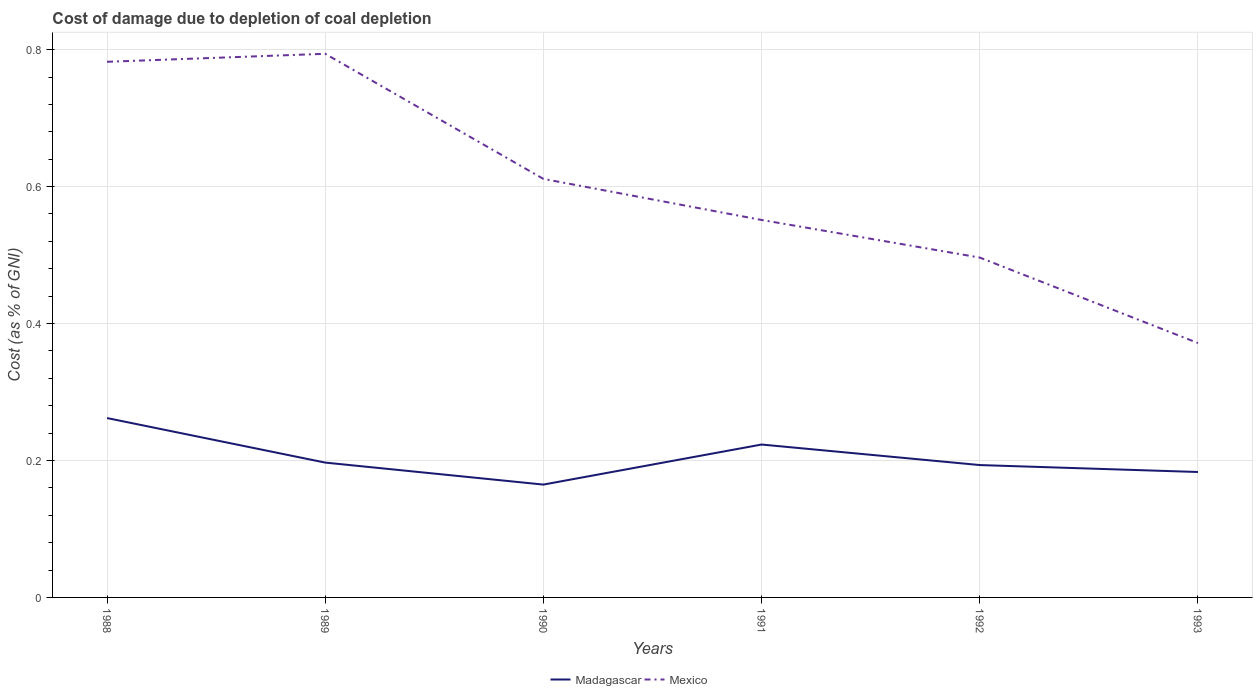How many different coloured lines are there?
Offer a terse response. 2. Does the line corresponding to Mexico intersect with the line corresponding to Madagascar?
Keep it short and to the point. No. Across all years, what is the maximum cost of damage caused due to coal depletion in Madagascar?
Provide a succinct answer. 0.16. What is the total cost of damage caused due to coal depletion in Madagascar in the graph?
Give a very brief answer. 0. What is the difference between the highest and the second highest cost of damage caused due to coal depletion in Mexico?
Your answer should be very brief. 0.42. What is the difference between two consecutive major ticks on the Y-axis?
Make the answer very short. 0.2. Are the values on the major ticks of Y-axis written in scientific E-notation?
Give a very brief answer. No. Does the graph contain any zero values?
Provide a succinct answer. No. Does the graph contain grids?
Your answer should be very brief. Yes. How many legend labels are there?
Your response must be concise. 2. What is the title of the graph?
Your answer should be very brief. Cost of damage due to depletion of coal depletion. Does "Brazil" appear as one of the legend labels in the graph?
Give a very brief answer. No. What is the label or title of the X-axis?
Keep it short and to the point. Years. What is the label or title of the Y-axis?
Your response must be concise. Cost (as % of GNI). What is the Cost (as % of GNI) in Madagascar in 1988?
Provide a short and direct response. 0.26. What is the Cost (as % of GNI) in Mexico in 1988?
Your answer should be compact. 0.78. What is the Cost (as % of GNI) in Madagascar in 1989?
Your answer should be very brief. 0.2. What is the Cost (as % of GNI) of Mexico in 1989?
Ensure brevity in your answer.  0.79. What is the Cost (as % of GNI) of Madagascar in 1990?
Give a very brief answer. 0.16. What is the Cost (as % of GNI) in Mexico in 1990?
Offer a very short reply. 0.61. What is the Cost (as % of GNI) of Madagascar in 1991?
Your response must be concise. 0.22. What is the Cost (as % of GNI) of Mexico in 1991?
Give a very brief answer. 0.55. What is the Cost (as % of GNI) in Madagascar in 1992?
Provide a succinct answer. 0.19. What is the Cost (as % of GNI) of Mexico in 1992?
Your answer should be compact. 0.5. What is the Cost (as % of GNI) in Madagascar in 1993?
Your answer should be compact. 0.18. What is the Cost (as % of GNI) in Mexico in 1993?
Your answer should be compact. 0.37. Across all years, what is the maximum Cost (as % of GNI) in Madagascar?
Make the answer very short. 0.26. Across all years, what is the maximum Cost (as % of GNI) of Mexico?
Ensure brevity in your answer.  0.79. Across all years, what is the minimum Cost (as % of GNI) in Madagascar?
Your answer should be very brief. 0.16. Across all years, what is the minimum Cost (as % of GNI) in Mexico?
Provide a succinct answer. 0.37. What is the total Cost (as % of GNI) in Madagascar in the graph?
Give a very brief answer. 1.22. What is the total Cost (as % of GNI) of Mexico in the graph?
Give a very brief answer. 3.61. What is the difference between the Cost (as % of GNI) in Madagascar in 1988 and that in 1989?
Offer a terse response. 0.07. What is the difference between the Cost (as % of GNI) of Mexico in 1988 and that in 1989?
Your answer should be compact. -0.01. What is the difference between the Cost (as % of GNI) of Madagascar in 1988 and that in 1990?
Ensure brevity in your answer.  0.1. What is the difference between the Cost (as % of GNI) of Mexico in 1988 and that in 1990?
Give a very brief answer. 0.17. What is the difference between the Cost (as % of GNI) of Madagascar in 1988 and that in 1991?
Provide a succinct answer. 0.04. What is the difference between the Cost (as % of GNI) of Mexico in 1988 and that in 1991?
Provide a short and direct response. 0.23. What is the difference between the Cost (as % of GNI) in Madagascar in 1988 and that in 1992?
Your answer should be compact. 0.07. What is the difference between the Cost (as % of GNI) in Mexico in 1988 and that in 1992?
Your response must be concise. 0.29. What is the difference between the Cost (as % of GNI) in Madagascar in 1988 and that in 1993?
Your answer should be very brief. 0.08. What is the difference between the Cost (as % of GNI) of Mexico in 1988 and that in 1993?
Keep it short and to the point. 0.41. What is the difference between the Cost (as % of GNI) of Madagascar in 1989 and that in 1990?
Offer a terse response. 0.03. What is the difference between the Cost (as % of GNI) of Mexico in 1989 and that in 1990?
Give a very brief answer. 0.18. What is the difference between the Cost (as % of GNI) in Madagascar in 1989 and that in 1991?
Your answer should be compact. -0.03. What is the difference between the Cost (as % of GNI) in Mexico in 1989 and that in 1991?
Keep it short and to the point. 0.24. What is the difference between the Cost (as % of GNI) in Madagascar in 1989 and that in 1992?
Provide a succinct answer. 0. What is the difference between the Cost (as % of GNI) in Mexico in 1989 and that in 1992?
Make the answer very short. 0.3. What is the difference between the Cost (as % of GNI) of Madagascar in 1989 and that in 1993?
Ensure brevity in your answer.  0.01. What is the difference between the Cost (as % of GNI) of Mexico in 1989 and that in 1993?
Your answer should be very brief. 0.42. What is the difference between the Cost (as % of GNI) of Madagascar in 1990 and that in 1991?
Provide a short and direct response. -0.06. What is the difference between the Cost (as % of GNI) in Madagascar in 1990 and that in 1992?
Your answer should be very brief. -0.03. What is the difference between the Cost (as % of GNI) of Mexico in 1990 and that in 1992?
Provide a succinct answer. 0.11. What is the difference between the Cost (as % of GNI) in Madagascar in 1990 and that in 1993?
Your response must be concise. -0.02. What is the difference between the Cost (as % of GNI) of Mexico in 1990 and that in 1993?
Your response must be concise. 0.24. What is the difference between the Cost (as % of GNI) in Madagascar in 1991 and that in 1992?
Offer a terse response. 0.03. What is the difference between the Cost (as % of GNI) in Mexico in 1991 and that in 1992?
Ensure brevity in your answer.  0.05. What is the difference between the Cost (as % of GNI) of Madagascar in 1991 and that in 1993?
Provide a succinct answer. 0.04. What is the difference between the Cost (as % of GNI) of Mexico in 1991 and that in 1993?
Your response must be concise. 0.18. What is the difference between the Cost (as % of GNI) in Madagascar in 1992 and that in 1993?
Make the answer very short. 0.01. What is the difference between the Cost (as % of GNI) in Mexico in 1992 and that in 1993?
Offer a very short reply. 0.12. What is the difference between the Cost (as % of GNI) of Madagascar in 1988 and the Cost (as % of GNI) of Mexico in 1989?
Ensure brevity in your answer.  -0.53. What is the difference between the Cost (as % of GNI) in Madagascar in 1988 and the Cost (as % of GNI) in Mexico in 1990?
Give a very brief answer. -0.35. What is the difference between the Cost (as % of GNI) in Madagascar in 1988 and the Cost (as % of GNI) in Mexico in 1991?
Offer a terse response. -0.29. What is the difference between the Cost (as % of GNI) in Madagascar in 1988 and the Cost (as % of GNI) in Mexico in 1992?
Provide a succinct answer. -0.23. What is the difference between the Cost (as % of GNI) of Madagascar in 1988 and the Cost (as % of GNI) of Mexico in 1993?
Keep it short and to the point. -0.11. What is the difference between the Cost (as % of GNI) in Madagascar in 1989 and the Cost (as % of GNI) in Mexico in 1990?
Ensure brevity in your answer.  -0.41. What is the difference between the Cost (as % of GNI) of Madagascar in 1989 and the Cost (as % of GNI) of Mexico in 1991?
Give a very brief answer. -0.35. What is the difference between the Cost (as % of GNI) of Madagascar in 1989 and the Cost (as % of GNI) of Mexico in 1992?
Keep it short and to the point. -0.3. What is the difference between the Cost (as % of GNI) of Madagascar in 1989 and the Cost (as % of GNI) of Mexico in 1993?
Provide a succinct answer. -0.17. What is the difference between the Cost (as % of GNI) of Madagascar in 1990 and the Cost (as % of GNI) of Mexico in 1991?
Provide a short and direct response. -0.39. What is the difference between the Cost (as % of GNI) of Madagascar in 1990 and the Cost (as % of GNI) of Mexico in 1992?
Provide a short and direct response. -0.33. What is the difference between the Cost (as % of GNI) of Madagascar in 1990 and the Cost (as % of GNI) of Mexico in 1993?
Provide a succinct answer. -0.21. What is the difference between the Cost (as % of GNI) in Madagascar in 1991 and the Cost (as % of GNI) in Mexico in 1992?
Ensure brevity in your answer.  -0.27. What is the difference between the Cost (as % of GNI) in Madagascar in 1991 and the Cost (as % of GNI) in Mexico in 1993?
Your answer should be very brief. -0.15. What is the difference between the Cost (as % of GNI) of Madagascar in 1992 and the Cost (as % of GNI) of Mexico in 1993?
Offer a terse response. -0.18. What is the average Cost (as % of GNI) in Madagascar per year?
Provide a short and direct response. 0.2. What is the average Cost (as % of GNI) in Mexico per year?
Your response must be concise. 0.6. In the year 1988, what is the difference between the Cost (as % of GNI) of Madagascar and Cost (as % of GNI) of Mexico?
Provide a succinct answer. -0.52. In the year 1989, what is the difference between the Cost (as % of GNI) in Madagascar and Cost (as % of GNI) in Mexico?
Your response must be concise. -0.6. In the year 1990, what is the difference between the Cost (as % of GNI) in Madagascar and Cost (as % of GNI) in Mexico?
Ensure brevity in your answer.  -0.45. In the year 1991, what is the difference between the Cost (as % of GNI) in Madagascar and Cost (as % of GNI) in Mexico?
Your response must be concise. -0.33. In the year 1992, what is the difference between the Cost (as % of GNI) in Madagascar and Cost (as % of GNI) in Mexico?
Keep it short and to the point. -0.3. In the year 1993, what is the difference between the Cost (as % of GNI) in Madagascar and Cost (as % of GNI) in Mexico?
Provide a succinct answer. -0.19. What is the ratio of the Cost (as % of GNI) of Madagascar in 1988 to that in 1989?
Provide a succinct answer. 1.33. What is the ratio of the Cost (as % of GNI) in Madagascar in 1988 to that in 1990?
Make the answer very short. 1.59. What is the ratio of the Cost (as % of GNI) of Mexico in 1988 to that in 1990?
Keep it short and to the point. 1.28. What is the ratio of the Cost (as % of GNI) of Madagascar in 1988 to that in 1991?
Your response must be concise. 1.17. What is the ratio of the Cost (as % of GNI) of Mexico in 1988 to that in 1991?
Offer a very short reply. 1.42. What is the ratio of the Cost (as % of GNI) of Madagascar in 1988 to that in 1992?
Your answer should be very brief. 1.36. What is the ratio of the Cost (as % of GNI) of Mexico in 1988 to that in 1992?
Ensure brevity in your answer.  1.58. What is the ratio of the Cost (as % of GNI) in Madagascar in 1988 to that in 1993?
Give a very brief answer. 1.43. What is the ratio of the Cost (as % of GNI) in Mexico in 1988 to that in 1993?
Give a very brief answer. 2.11. What is the ratio of the Cost (as % of GNI) in Madagascar in 1989 to that in 1990?
Offer a very short reply. 1.19. What is the ratio of the Cost (as % of GNI) of Mexico in 1989 to that in 1990?
Make the answer very short. 1.3. What is the ratio of the Cost (as % of GNI) of Madagascar in 1989 to that in 1991?
Your response must be concise. 0.88. What is the ratio of the Cost (as % of GNI) in Mexico in 1989 to that in 1991?
Give a very brief answer. 1.44. What is the ratio of the Cost (as % of GNI) of Madagascar in 1989 to that in 1992?
Ensure brevity in your answer.  1.02. What is the ratio of the Cost (as % of GNI) of Mexico in 1989 to that in 1992?
Ensure brevity in your answer.  1.6. What is the ratio of the Cost (as % of GNI) in Madagascar in 1989 to that in 1993?
Make the answer very short. 1.08. What is the ratio of the Cost (as % of GNI) in Mexico in 1989 to that in 1993?
Your answer should be very brief. 2.14. What is the ratio of the Cost (as % of GNI) of Madagascar in 1990 to that in 1991?
Offer a terse response. 0.74. What is the ratio of the Cost (as % of GNI) of Mexico in 1990 to that in 1991?
Offer a terse response. 1.11. What is the ratio of the Cost (as % of GNI) in Madagascar in 1990 to that in 1992?
Your response must be concise. 0.85. What is the ratio of the Cost (as % of GNI) of Mexico in 1990 to that in 1992?
Give a very brief answer. 1.23. What is the ratio of the Cost (as % of GNI) of Madagascar in 1990 to that in 1993?
Offer a terse response. 0.9. What is the ratio of the Cost (as % of GNI) in Mexico in 1990 to that in 1993?
Offer a very short reply. 1.65. What is the ratio of the Cost (as % of GNI) in Madagascar in 1991 to that in 1992?
Offer a terse response. 1.16. What is the ratio of the Cost (as % of GNI) in Mexico in 1991 to that in 1992?
Provide a short and direct response. 1.11. What is the ratio of the Cost (as % of GNI) of Madagascar in 1991 to that in 1993?
Make the answer very short. 1.22. What is the ratio of the Cost (as % of GNI) of Mexico in 1991 to that in 1993?
Offer a terse response. 1.48. What is the ratio of the Cost (as % of GNI) in Madagascar in 1992 to that in 1993?
Ensure brevity in your answer.  1.06. What is the ratio of the Cost (as % of GNI) of Mexico in 1992 to that in 1993?
Your answer should be very brief. 1.34. What is the difference between the highest and the second highest Cost (as % of GNI) in Madagascar?
Offer a terse response. 0.04. What is the difference between the highest and the second highest Cost (as % of GNI) in Mexico?
Make the answer very short. 0.01. What is the difference between the highest and the lowest Cost (as % of GNI) in Madagascar?
Your answer should be compact. 0.1. What is the difference between the highest and the lowest Cost (as % of GNI) of Mexico?
Offer a terse response. 0.42. 